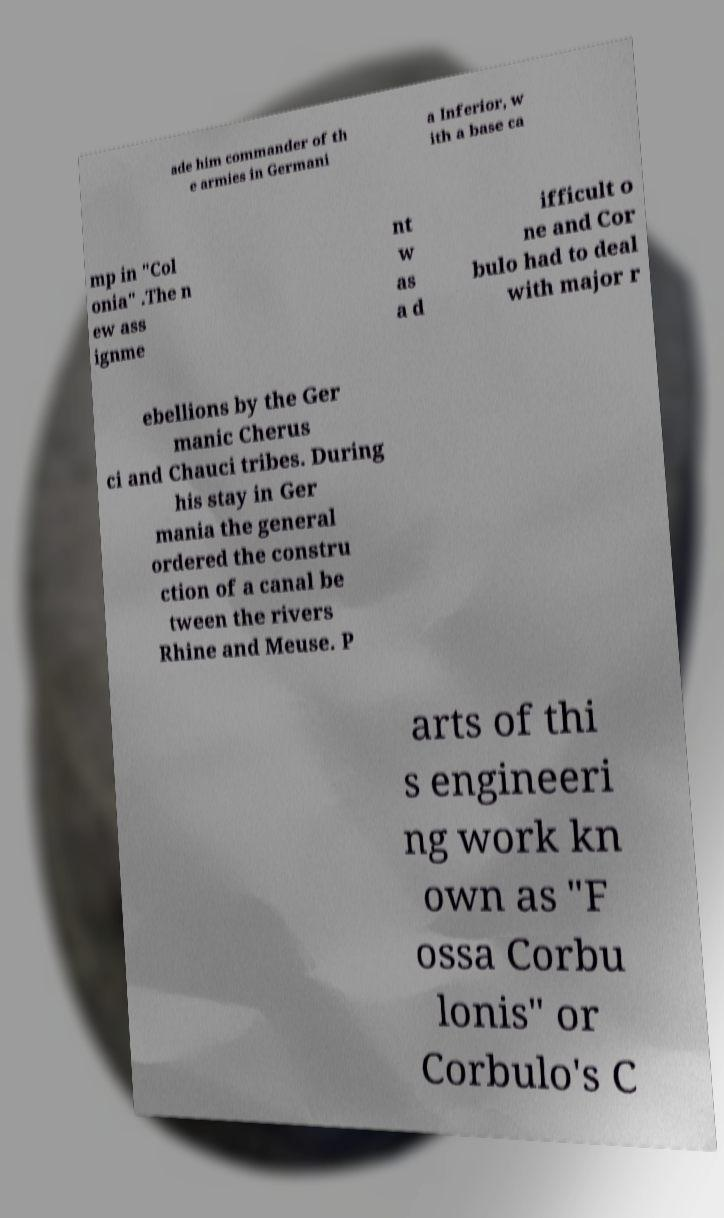Could you assist in decoding the text presented in this image and type it out clearly? ade him commander of th e armies in Germani a Inferior, w ith a base ca mp in "Col onia" .The n ew ass ignme nt w as a d ifficult o ne and Cor bulo had to deal with major r ebellions by the Ger manic Cherus ci and Chauci tribes. During his stay in Ger mania the general ordered the constru ction of a canal be tween the rivers Rhine and Meuse. P arts of thi s engineeri ng work kn own as "F ossa Corbu lonis" or Corbulo's C 